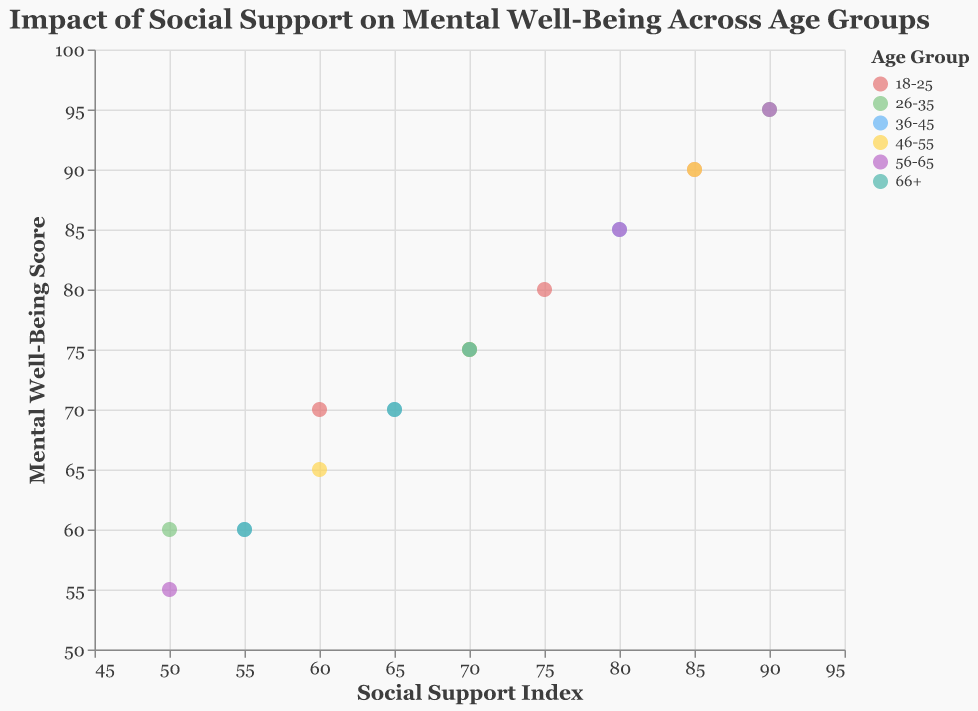What is the title of the scatter plot? The title is usually displayed at the top of the figure and provides a summary of what the plot is about. Here, the title is: "Impact of Social Support on Mental Well-Being Across Age Groups".
Answer: "Impact of Social Support on Mental Well-Being Across Age Groups" Which age group has the highest Social Support Index? To answer this, look for the age group with the highest point on the X-axis. The data point with the highest Social Support Index (90) belongs to the age groups 26-35 and 56-65.
Answer: 26-35 and 56-65 What is the Mental Well-Being Score for the age group 36-45 with a Social Support Index of 55? Find the data point for the age group 36-45 and locate the score on the Y-axis corresponding to the Social Support Index of 55. This score is 60.
Answer: 60 Compare the Mental Well-Being Scores for age groups 46-55 and 56-65 when the Social Support Index is 80. Which one is higher? Find the points where Social Support Index is 80 for both age groups. The Mental Well-Being Score for 46-55 is not recorded at this index, but for 56-65, the score is 85. So, the score is higher for the 56-65 group.
Answer: 56-65 What is the average Mental Well-Being Score for the age group 18-25? Calculate the average by adding the Mental Well-Being Scores (80, 70, and 90), which equals 240, and then dividing by 3 (the number of data points). The average score is 240/3 = 80.
Answer: 80 Is there a positive correlation between Social Support Index and Mental Well-Being Score across all age groups? To determine correlation, observe whether higher Social Support Index values generally align with higher Mental Well-Being Scores. The data consistently show higher scores with higher indices, suggesting a positive correlation.
Answer: Yes Which age group shows the most variation in its Mental Well-Being Scores? To see variation, look at the spread of the points along the Y-axis for each age group. The 56-65 age group has the widest range from 55 to 95, indicating the most variation.
Answer: 56-65 What is the Mental Well-Being Score for the age group 26-35 with the lowest Social Support Index? Find the data point for the age group 26-35 with the lowest Social Support Index (50) and then check the corresponding Mental Well-Being Score, which is 60.
Answer: 60 How many different colors are used to represent the age groups in the scatter plot? The legend shows different colors for each age group. Counting these, we see that six colors are used, one for each age group: 18-25, 26-35, 36-45, 46-55, 56-65, and 66+.
Answer: Six 